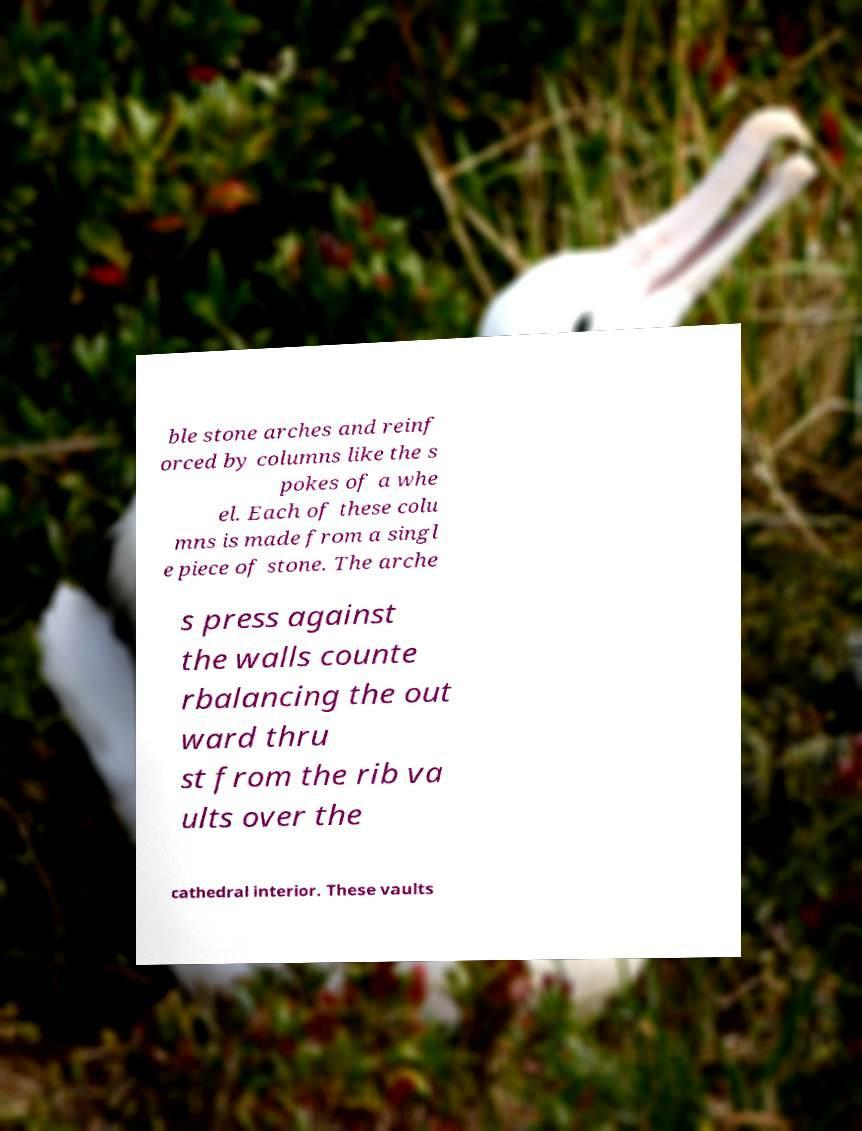Could you extract and type out the text from this image? ble stone arches and reinf orced by columns like the s pokes of a whe el. Each of these colu mns is made from a singl e piece of stone. The arche s press against the walls counte rbalancing the out ward thru st from the rib va ults over the cathedral interior. These vaults 